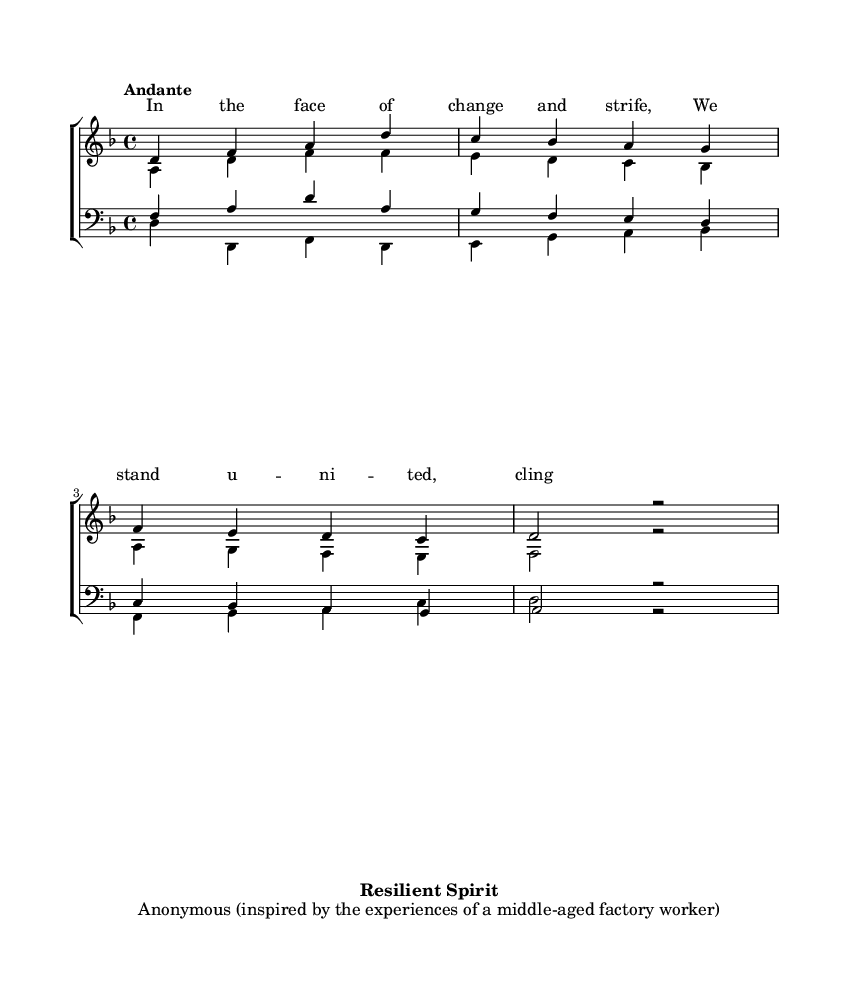What is the key signature of this music? The key signature is D minor, which has one flat (B flat). This is identified by looking at the key signature indicator at the beginning of the staff.
Answer: D minor What is the time signature of this music? The time signature is 4/4, which is indicated at the beginning of the score. This means there are four beats per measure.
Answer: 4/4 What is the tempo marking for this piece? The tempo marking is "Andante", which suggests a moderately slow tempo. This is found written above the staff.
Answer: Andante How many vocal parts are there in this choral work? There are four vocal parts: soprano, alto, tenor, and bass. This can be confirmed by observing the separate staves for each voice type.
Answer: Four How does the soprano melody relate to the theme of resilience? The soprano melody embodies the theme of resilience as it rises and falls, symbolizing the struggle against hardship while maintaining a hopeful trajectory. This interpretation comes from analyzing how the notes interact with the lyrics that express unity in strife.
Answer: Through melodic rise and fall What is the function of the bass part in this choral work? The bass part serves to support the harmony and provide a foundation for the other voices, contributing to the overall richness of the choral texture. This is evident as it outlines the root notes and harmonizes with the other parts.
Answer: To support harmony What is the text of the first line of lyrics? The first line of lyrics is "In the face of change and strife," which is directly seen in the lyric section under the soprano part.
Answer: In the face of change and strife 